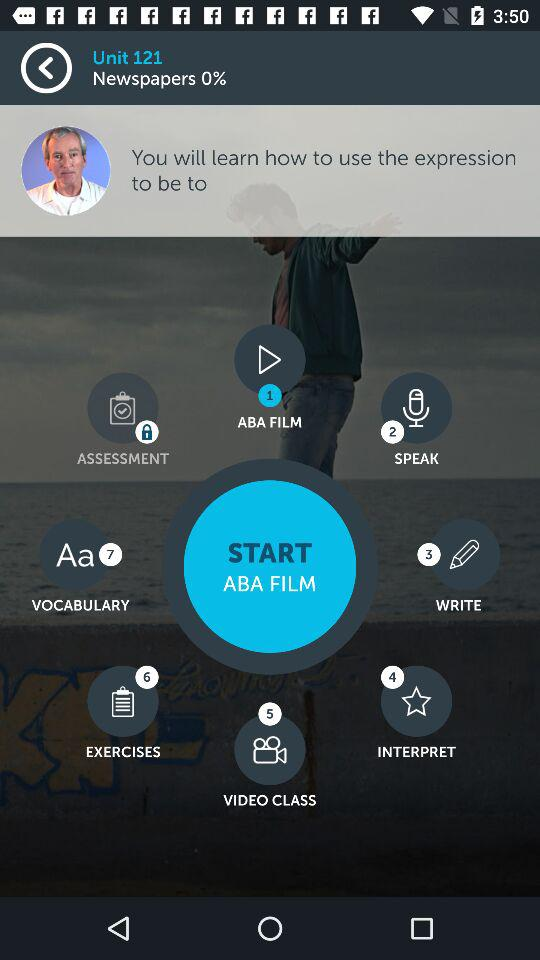Which option is locked? The locked option is "ASSESSMENT". 